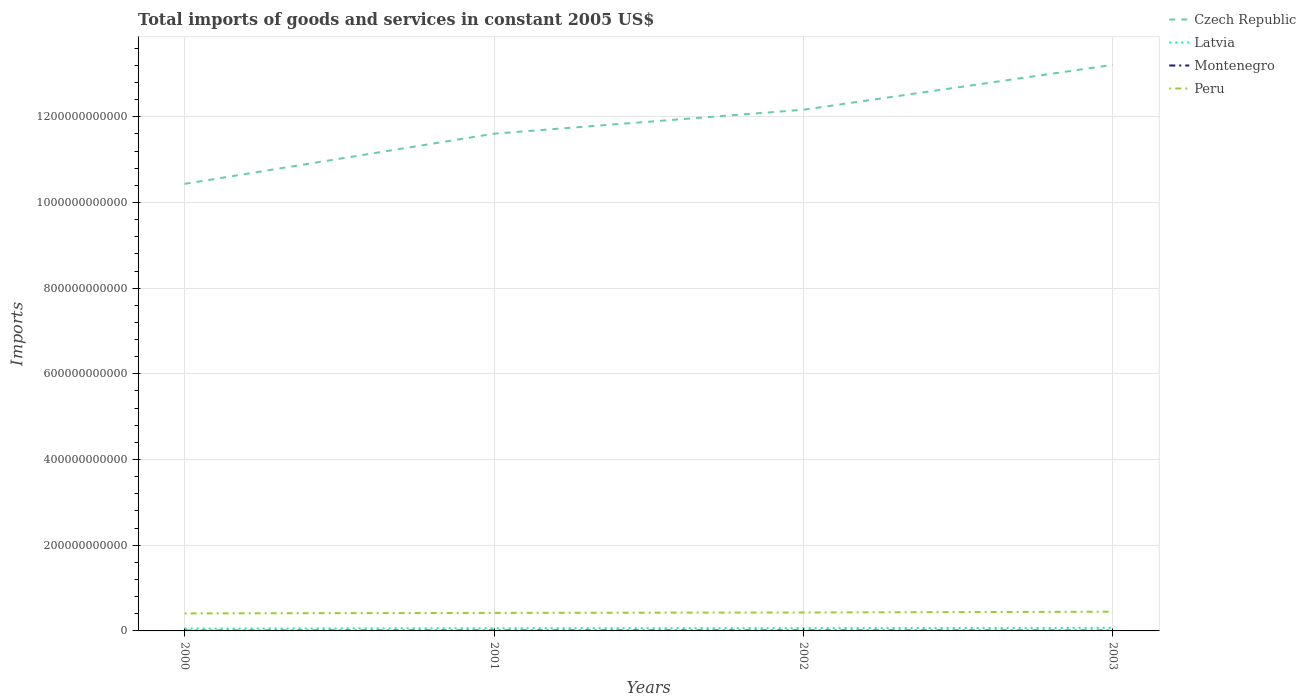How many different coloured lines are there?
Ensure brevity in your answer.  4. Across all years, what is the maximum total imports of goods and services in Czech Republic?
Ensure brevity in your answer.  1.04e+12. What is the total total imports of goods and services in Montenegro in the graph?
Ensure brevity in your answer.  -3.51e+08. What is the difference between the highest and the second highest total imports of goods and services in Montenegro?
Your response must be concise. 3.78e+08. What is the difference between the highest and the lowest total imports of goods and services in Latvia?
Ensure brevity in your answer.  2. Is the total imports of goods and services in Peru strictly greater than the total imports of goods and services in Latvia over the years?
Keep it short and to the point. No. How many years are there in the graph?
Offer a terse response. 4. What is the difference between two consecutive major ticks on the Y-axis?
Your answer should be very brief. 2.00e+11. Where does the legend appear in the graph?
Give a very brief answer. Top right. How many legend labels are there?
Keep it short and to the point. 4. How are the legend labels stacked?
Your answer should be compact. Vertical. What is the title of the graph?
Your answer should be compact. Total imports of goods and services in constant 2005 US$. Does "Burundi" appear as one of the legend labels in the graph?
Make the answer very short. No. What is the label or title of the X-axis?
Offer a terse response. Years. What is the label or title of the Y-axis?
Provide a succinct answer. Imports. What is the Imports in Czech Republic in 2000?
Provide a succinct answer. 1.04e+12. What is the Imports of Latvia in 2000?
Offer a very short reply. 5.39e+09. What is the Imports of Montenegro in 2000?
Provide a succinct answer. 5.45e+08. What is the Imports in Peru in 2000?
Provide a short and direct response. 4.09e+1. What is the Imports in Czech Republic in 2001?
Offer a very short reply. 1.16e+12. What is the Imports in Latvia in 2001?
Offer a terse response. 6.23e+09. What is the Imports in Montenegro in 2001?
Offer a terse response. 8.95e+08. What is the Imports in Peru in 2001?
Give a very brief answer. 4.21e+1. What is the Imports in Czech Republic in 2002?
Offer a terse response. 1.22e+12. What is the Imports in Latvia in 2002?
Make the answer very short. 6.40e+09. What is the Imports of Montenegro in 2002?
Make the answer very short. 9.23e+08. What is the Imports in Peru in 2002?
Keep it short and to the point. 4.30e+1. What is the Imports in Czech Republic in 2003?
Offer a very short reply. 1.32e+12. What is the Imports of Latvia in 2003?
Keep it short and to the point. 7.16e+09. What is the Imports in Montenegro in 2003?
Offer a very short reply. 6.96e+08. What is the Imports in Peru in 2003?
Offer a very short reply. 4.48e+1. Across all years, what is the maximum Imports in Czech Republic?
Make the answer very short. 1.32e+12. Across all years, what is the maximum Imports in Latvia?
Give a very brief answer. 7.16e+09. Across all years, what is the maximum Imports of Montenegro?
Your answer should be very brief. 9.23e+08. Across all years, what is the maximum Imports of Peru?
Provide a succinct answer. 4.48e+1. Across all years, what is the minimum Imports in Czech Republic?
Your answer should be compact. 1.04e+12. Across all years, what is the minimum Imports in Latvia?
Your answer should be very brief. 5.39e+09. Across all years, what is the minimum Imports in Montenegro?
Your answer should be compact. 5.45e+08. Across all years, what is the minimum Imports of Peru?
Your response must be concise. 4.09e+1. What is the total Imports in Czech Republic in the graph?
Your response must be concise. 4.74e+12. What is the total Imports of Latvia in the graph?
Give a very brief answer. 2.52e+1. What is the total Imports in Montenegro in the graph?
Give a very brief answer. 3.06e+09. What is the total Imports in Peru in the graph?
Provide a succinct answer. 1.71e+11. What is the difference between the Imports in Czech Republic in 2000 and that in 2001?
Keep it short and to the point. -1.17e+11. What is the difference between the Imports in Latvia in 2000 and that in 2001?
Provide a short and direct response. -8.43e+08. What is the difference between the Imports in Montenegro in 2000 and that in 2001?
Keep it short and to the point. -3.51e+08. What is the difference between the Imports in Peru in 2000 and that in 2001?
Ensure brevity in your answer.  -1.18e+09. What is the difference between the Imports in Czech Republic in 2000 and that in 2002?
Your response must be concise. -1.73e+11. What is the difference between the Imports of Latvia in 2000 and that in 2002?
Provide a short and direct response. -1.01e+09. What is the difference between the Imports of Montenegro in 2000 and that in 2002?
Offer a very short reply. -3.78e+08. What is the difference between the Imports of Peru in 2000 and that in 2002?
Provide a succinct answer. -2.16e+09. What is the difference between the Imports in Czech Republic in 2000 and that in 2003?
Provide a short and direct response. -2.78e+11. What is the difference between the Imports of Latvia in 2000 and that in 2003?
Your answer should be very brief. -1.77e+09. What is the difference between the Imports in Montenegro in 2000 and that in 2003?
Offer a very short reply. -1.51e+08. What is the difference between the Imports in Peru in 2000 and that in 2003?
Offer a terse response. -3.95e+09. What is the difference between the Imports in Czech Republic in 2001 and that in 2002?
Your response must be concise. -5.59e+1. What is the difference between the Imports of Latvia in 2001 and that in 2002?
Give a very brief answer. -1.69e+08. What is the difference between the Imports in Montenegro in 2001 and that in 2002?
Your answer should be compact. -2.75e+07. What is the difference between the Imports of Peru in 2001 and that in 2002?
Your answer should be very brief. -9.76e+08. What is the difference between the Imports in Czech Republic in 2001 and that in 2003?
Make the answer very short. -1.61e+11. What is the difference between the Imports of Latvia in 2001 and that in 2003?
Your response must be concise. -9.29e+08. What is the difference between the Imports of Montenegro in 2001 and that in 2003?
Provide a succinct answer. 2.00e+08. What is the difference between the Imports of Peru in 2001 and that in 2003?
Offer a very short reply. -2.77e+09. What is the difference between the Imports in Czech Republic in 2002 and that in 2003?
Ensure brevity in your answer.  -1.05e+11. What is the difference between the Imports of Latvia in 2002 and that in 2003?
Keep it short and to the point. -7.60e+08. What is the difference between the Imports in Montenegro in 2002 and that in 2003?
Make the answer very short. 2.27e+08. What is the difference between the Imports of Peru in 2002 and that in 2003?
Your answer should be compact. -1.80e+09. What is the difference between the Imports in Czech Republic in 2000 and the Imports in Latvia in 2001?
Ensure brevity in your answer.  1.04e+12. What is the difference between the Imports of Czech Republic in 2000 and the Imports of Montenegro in 2001?
Make the answer very short. 1.04e+12. What is the difference between the Imports of Czech Republic in 2000 and the Imports of Peru in 2001?
Offer a terse response. 1.00e+12. What is the difference between the Imports of Latvia in 2000 and the Imports of Montenegro in 2001?
Your response must be concise. 4.50e+09. What is the difference between the Imports of Latvia in 2000 and the Imports of Peru in 2001?
Make the answer very short. -3.67e+1. What is the difference between the Imports of Montenegro in 2000 and the Imports of Peru in 2001?
Ensure brevity in your answer.  -4.15e+1. What is the difference between the Imports of Czech Republic in 2000 and the Imports of Latvia in 2002?
Keep it short and to the point. 1.04e+12. What is the difference between the Imports in Czech Republic in 2000 and the Imports in Montenegro in 2002?
Ensure brevity in your answer.  1.04e+12. What is the difference between the Imports of Czech Republic in 2000 and the Imports of Peru in 2002?
Provide a short and direct response. 1.00e+12. What is the difference between the Imports of Latvia in 2000 and the Imports of Montenegro in 2002?
Your answer should be compact. 4.47e+09. What is the difference between the Imports in Latvia in 2000 and the Imports in Peru in 2002?
Provide a short and direct response. -3.77e+1. What is the difference between the Imports of Montenegro in 2000 and the Imports of Peru in 2002?
Offer a terse response. -4.25e+1. What is the difference between the Imports of Czech Republic in 2000 and the Imports of Latvia in 2003?
Make the answer very short. 1.04e+12. What is the difference between the Imports in Czech Republic in 2000 and the Imports in Montenegro in 2003?
Your answer should be very brief. 1.04e+12. What is the difference between the Imports of Czech Republic in 2000 and the Imports of Peru in 2003?
Offer a very short reply. 9.99e+11. What is the difference between the Imports of Latvia in 2000 and the Imports of Montenegro in 2003?
Your answer should be very brief. 4.70e+09. What is the difference between the Imports of Latvia in 2000 and the Imports of Peru in 2003?
Make the answer very short. -3.95e+1. What is the difference between the Imports in Montenegro in 2000 and the Imports in Peru in 2003?
Ensure brevity in your answer.  -4.43e+1. What is the difference between the Imports in Czech Republic in 2001 and the Imports in Latvia in 2002?
Your response must be concise. 1.15e+12. What is the difference between the Imports of Czech Republic in 2001 and the Imports of Montenegro in 2002?
Your answer should be very brief. 1.16e+12. What is the difference between the Imports in Czech Republic in 2001 and the Imports in Peru in 2002?
Give a very brief answer. 1.12e+12. What is the difference between the Imports of Latvia in 2001 and the Imports of Montenegro in 2002?
Provide a succinct answer. 5.31e+09. What is the difference between the Imports of Latvia in 2001 and the Imports of Peru in 2002?
Provide a short and direct response. -3.68e+1. What is the difference between the Imports of Montenegro in 2001 and the Imports of Peru in 2002?
Offer a terse response. -4.22e+1. What is the difference between the Imports in Czech Republic in 2001 and the Imports in Latvia in 2003?
Provide a short and direct response. 1.15e+12. What is the difference between the Imports in Czech Republic in 2001 and the Imports in Montenegro in 2003?
Your response must be concise. 1.16e+12. What is the difference between the Imports in Czech Republic in 2001 and the Imports in Peru in 2003?
Give a very brief answer. 1.12e+12. What is the difference between the Imports in Latvia in 2001 and the Imports in Montenegro in 2003?
Keep it short and to the point. 5.54e+09. What is the difference between the Imports in Latvia in 2001 and the Imports in Peru in 2003?
Provide a short and direct response. -3.86e+1. What is the difference between the Imports in Montenegro in 2001 and the Imports in Peru in 2003?
Your response must be concise. -4.39e+1. What is the difference between the Imports in Czech Republic in 2002 and the Imports in Latvia in 2003?
Provide a short and direct response. 1.21e+12. What is the difference between the Imports of Czech Republic in 2002 and the Imports of Montenegro in 2003?
Offer a very short reply. 1.22e+12. What is the difference between the Imports of Czech Republic in 2002 and the Imports of Peru in 2003?
Your answer should be compact. 1.17e+12. What is the difference between the Imports of Latvia in 2002 and the Imports of Montenegro in 2003?
Your response must be concise. 5.71e+09. What is the difference between the Imports in Latvia in 2002 and the Imports in Peru in 2003?
Provide a succinct answer. -3.84e+1. What is the difference between the Imports in Montenegro in 2002 and the Imports in Peru in 2003?
Offer a terse response. -4.39e+1. What is the average Imports in Czech Republic per year?
Make the answer very short. 1.19e+12. What is the average Imports in Latvia per year?
Keep it short and to the point. 6.30e+09. What is the average Imports in Montenegro per year?
Ensure brevity in your answer.  7.65e+08. What is the average Imports of Peru per year?
Provide a succinct answer. 4.27e+1. In the year 2000, what is the difference between the Imports of Czech Republic and Imports of Latvia?
Offer a very short reply. 1.04e+12. In the year 2000, what is the difference between the Imports in Czech Republic and Imports in Montenegro?
Keep it short and to the point. 1.04e+12. In the year 2000, what is the difference between the Imports in Czech Republic and Imports in Peru?
Your response must be concise. 1.00e+12. In the year 2000, what is the difference between the Imports in Latvia and Imports in Montenegro?
Make the answer very short. 4.85e+09. In the year 2000, what is the difference between the Imports in Latvia and Imports in Peru?
Offer a terse response. -3.55e+1. In the year 2000, what is the difference between the Imports of Montenegro and Imports of Peru?
Keep it short and to the point. -4.03e+1. In the year 2001, what is the difference between the Imports of Czech Republic and Imports of Latvia?
Offer a very short reply. 1.15e+12. In the year 2001, what is the difference between the Imports in Czech Republic and Imports in Montenegro?
Your response must be concise. 1.16e+12. In the year 2001, what is the difference between the Imports in Czech Republic and Imports in Peru?
Offer a terse response. 1.12e+12. In the year 2001, what is the difference between the Imports of Latvia and Imports of Montenegro?
Provide a succinct answer. 5.34e+09. In the year 2001, what is the difference between the Imports of Latvia and Imports of Peru?
Your answer should be very brief. -3.58e+1. In the year 2001, what is the difference between the Imports in Montenegro and Imports in Peru?
Your response must be concise. -4.12e+1. In the year 2002, what is the difference between the Imports in Czech Republic and Imports in Latvia?
Make the answer very short. 1.21e+12. In the year 2002, what is the difference between the Imports of Czech Republic and Imports of Montenegro?
Your answer should be compact. 1.22e+12. In the year 2002, what is the difference between the Imports of Czech Republic and Imports of Peru?
Offer a terse response. 1.17e+12. In the year 2002, what is the difference between the Imports in Latvia and Imports in Montenegro?
Offer a terse response. 5.48e+09. In the year 2002, what is the difference between the Imports in Latvia and Imports in Peru?
Your response must be concise. -3.66e+1. In the year 2002, what is the difference between the Imports in Montenegro and Imports in Peru?
Ensure brevity in your answer.  -4.21e+1. In the year 2003, what is the difference between the Imports in Czech Republic and Imports in Latvia?
Provide a short and direct response. 1.31e+12. In the year 2003, what is the difference between the Imports of Czech Republic and Imports of Montenegro?
Offer a terse response. 1.32e+12. In the year 2003, what is the difference between the Imports in Czech Republic and Imports in Peru?
Your answer should be compact. 1.28e+12. In the year 2003, what is the difference between the Imports of Latvia and Imports of Montenegro?
Your response must be concise. 6.47e+09. In the year 2003, what is the difference between the Imports of Latvia and Imports of Peru?
Provide a short and direct response. -3.77e+1. In the year 2003, what is the difference between the Imports of Montenegro and Imports of Peru?
Your answer should be compact. -4.41e+1. What is the ratio of the Imports in Czech Republic in 2000 to that in 2001?
Give a very brief answer. 0.9. What is the ratio of the Imports in Latvia in 2000 to that in 2001?
Keep it short and to the point. 0.86. What is the ratio of the Imports of Montenegro in 2000 to that in 2001?
Provide a short and direct response. 0.61. What is the ratio of the Imports in Peru in 2000 to that in 2001?
Give a very brief answer. 0.97. What is the ratio of the Imports of Czech Republic in 2000 to that in 2002?
Your answer should be very brief. 0.86. What is the ratio of the Imports in Latvia in 2000 to that in 2002?
Your answer should be very brief. 0.84. What is the ratio of the Imports of Montenegro in 2000 to that in 2002?
Provide a short and direct response. 0.59. What is the ratio of the Imports in Peru in 2000 to that in 2002?
Offer a terse response. 0.95. What is the ratio of the Imports in Czech Republic in 2000 to that in 2003?
Provide a succinct answer. 0.79. What is the ratio of the Imports of Latvia in 2000 to that in 2003?
Offer a terse response. 0.75. What is the ratio of the Imports in Montenegro in 2000 to that in 2003?
Make the answer very short. 0.78. What is the ratio of the Imports in Peru in 2000 to that in 2003?
Offer a very short reply. 0.91. What is the ratio of the Imports in Czech Republic in 2001 to that in 2002?
Your answer should be very brief. 0.95. What is the ratio of the Imports in Latvia in 2001 to that in 2002?
Make the answer very short. 0.97. What is the ratio of the Imports of Montenegro in 2001 to that in 2002?
Provide a short and direct response. 0.97. What is the ratio of the Imports in Peru in 2001 to that in 2002?
Your response must be concise. 0.98. What is the ratio of the Imports of Czech Republic in 2001 to that in 2003?
Keep it short and to the point. 0.88. What is the ratio of the Imports in Latvia in 2001 to that in 2003?
Your response must be concise. 0.87. What is the ratio of the Imports in Montenegro in 2001 to that in 2003?
Your answer should be compact. 1.29. What is the ratio of the Imports of Peru in 2001 to that in 2003?
Your answer should be compact. 0.94. What is the ratio of the Imports of Czech Republic in 2002 to that in 2003?
Offer a terse response. 0.92. What is the ratio of the Imports of Latvia in 2002 to that in 2003?
Make the answer very short. 0.89. What is the ratio of the Imports in Montenegro in 2002 to that in 2003?
Keep it short and to the point. 1.33. What is the ratio of the Imports of Peru in 2002 to that in 2003?
Provide a short and direct response. 0.96. What is the difference between the highest and the second highest Imports in Czech Republic?
Keep it short and to the point. 1.05e+11. What is the difference between the highest and the second highest Imports in Latvia?
Provide a short and direct response. 7.60e+08. What is the difference between the highest and the second highest Imports of Montenegro?
Provide a succinct answer. 2.75e+07. What is the difference between the highest and the second highest Imports in Peru?
Your response must be concise. 1.80e+09. What is the difference between the highest and the lowest Imports in Czech Republic?
Your answer should be compact. 2.78e+11. What is the difference between the highest and the lowest Imports of Latvia?
Give a very brief answer. 1.77e+09. What is the difference between the highest and the lowest Imports of Montenegro?
Make the answer very short. 3.78e+08. What is the difference between the highest and the lowest Imports of Peru?
Offer a very short reply. 3.95e+09. 